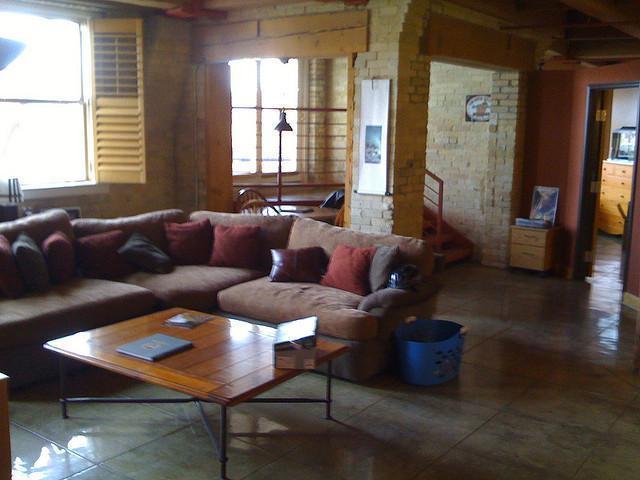What is on the table?
Select the accurate response from the four choices given to answer the question.
Options: Ash tray, flowers, book, dog. Book. 